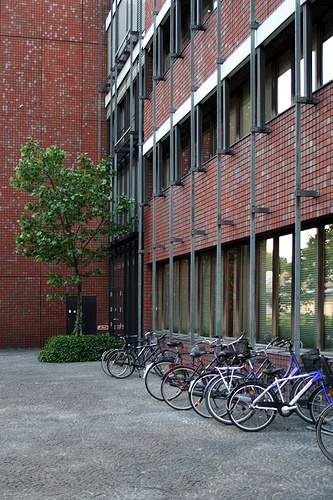Describe the objects in this image and their specific colors. I can see bicycle in brown, black, gray, navy, and lightgray tones, bicycle in brown, gray, black, darkgray, and navy tones, bicycle in brown, black, gray, and darkgray tones, bicycle in brown, black, gray, darkgray, and blue tones, and bicycle in brown, darkgray, gray, black, and lightgray tones in this image. 